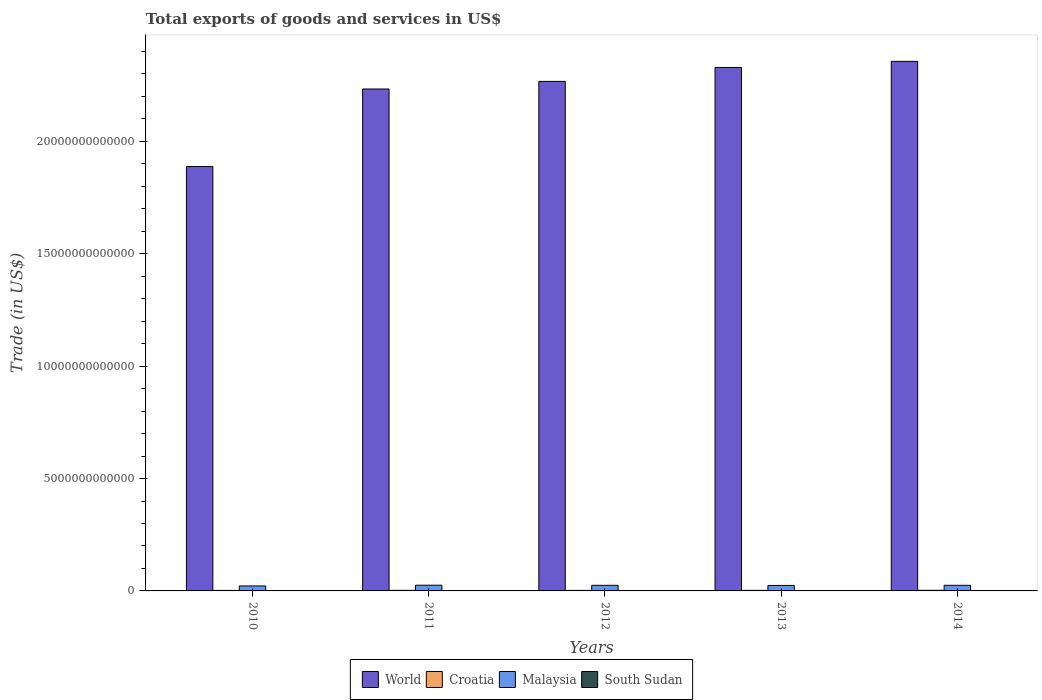How many different coloured bars are there?
Provide a short and direct response. 4. Are the number of bars on each tick of the X-axis equal?
Your answer should be very brief. Yes. How many bars are there on the 5th tick from the left?
Ensure brevity in your answer.  4. What is the label of the 5th group of bars from the left?
Your answer should be very brief. 2014. What is the total exports of goods and services in Malaysia in 2012?
Ensure brevity in your answer.  2.49e+11. Across all years, what is the maximum total exports of goods and services in Malaysia?
Give a very brief answer. 2.54e+11. Across all years, what is the minimum total exports of goods and services in World?
Give a very brief answer. 1.89e+13. In which year was the total exports of goods and services in World minimum?
Provide a short and direct response. 2010. What is the total total exports of goods and services in World in the graph?
Give a very brief answer. 1.11e+14. What is the difference between the total exports of goods and services in Croatia in 2010 and that in 2014?
Give a very brief answer. -3.91e+09. What is the difference between the total exports of goods and services in Malaysia in 2010 and the total exports of goods and services in Croatia in 2013?
Offer a very short reply. 1.97e+11. What is the average total exports of goods and services in World per year?
Offer a terse response. 2.21e+13. In the year 2013, what is the difference between the total exports of goods and services in Malaysia and total exports of goods and services in World?
Offer a very short reply. -2.30e+13. In how many years, is the total exports of goods and services in South Sudan greater than 4000000000000 US$?
Make the answer very short. 0. What is the ratio of the total exports of goods and services in Croatia in 2011 to that in 2014?
Give a very brief answer. 0.95. Is the total exports of goods and services in South Sudan in 2010 less than that in 2013?
Your answer should be very brief. No. What is the difference between the highest and the second highest total exports of goods and services in Croatia?
Provide a succinct answer. 1.28e+09. What is the difference between the highest and the lowest total exports of goods and services in Malaysia?
Offer a terse response. 3.23e+1. In how many years, is the total exports of goods and services in Malaysia greater than the average total exports of goods and services in Malaysia taken over all years?
Your response must be concise. 4. Is the sum of the total exports of goods and services in South Sudan in 2012 and 2013 greater than the maximum total exports of goods and services in World across all years?
Give a very brief answer. No. Is it the case that in every year, the sum of the total exports of goods and services in Croatia and total exports of goods and services in World is greater than the sum of total exports of goods and services in South Sudan and total exports of goods and services in Malaysia?
Offer a terse response. No. What does the 4th bar from the left in 2013 represents?
Give a very brief answer. South Sudan. What does the 3rd bar from the right in 2013 represents?
Offer a very short reply. Croatia. How many bars are there?
Give a very brief answer. 20. Are all the bars in the graph horizontal?
Offer a terse response. No. What is the difference between two consecutive major ticks on the Y-axis?
Your answer should be compact. 5.00e+12. Are the values on the major ticks of Y-axis written in scientific E-notation?
Offer a terse response. No. Does the graph contain grids?
Keep it short and to the point. No. Where does the legend appear in the graph?
Your response must be concise. Bottom center. What is the title of the graph?
Ensure brevity in your answer.  Total exports of goods and services in US$. Does "Kuwait" appear as one of the legend labels in the graph?
Your response must be concise. No. What is the label or title of the Y-axis?
Offer a terse response. Trade (in US$). What is the Trade (in US$) of World in 2010?
Provide a succinct answer. 1.89e+13. What is the Trade (in US$) of Croatia in 2010?
Offer a terse response. 2.25e+1. What is the Trade (in US$) of Malaysia in 2010?
Make the answer very short. 2.22e+11. What is the Trade (in US$) of South Sudan in 2010?
Give a very brief answer. 9.66e+09. What is the Trade (in US$) of World in 2011?
Provide a succinct answer. 2.23e+13. What is the Trade (in US$) of Croatia in 2011?
Provide a succinct answer. 2.52e+1. What is the Trade (in US$) of Malaysia in 2011?
Your response must be concise. 2.54e+11. What is the Trade (in US$) in South Sudan in 2011?
Offer a terse response. 1.18e+1. What is the Trade (in US$) in World in 2012?
Provide a short and direct response. 2.27e+13. What is the Trade (in US$) of Croatia in 2012?
Ensure brevity in your answer.  2.35e+1. What is the Trade (in US$) in Malaysia in 2012?
Provide a short and direct response. 2.49e+11. What is the Trade (in US$) of South Sudan in 2012?
Ensure brevity in your answer.  1.05e+09. What is the Trade (in US$) in World in 2013?
Your response must be concise. 2.33e+13. What is the Trade (in US$) in Croatia in 2013?
Provide a short and direct response. 2.49e+1. What is the Trade (in US$) in Malaysia in 2013?
Offer a terse response. 2.44e+11. What is the Trade (in US$) in South Sudan in 2013?
Your answer should be compact. 2.15e+09. What is the Trade (in US$) of World in 2014?
Offer a very short reply. 2.36e+13. What is the Trade (in US$) in Croatia in 2014?
Offer a terse response. 2.64e+1. What is the Trade (in US$) of Malaysia in 2014?
Provide a succinct answer. 2.50e+11. What is the Trade (in US$) of South Sudan in 2014?
Offer a terse response. 2.68e+09. Across all years, what is the maximum Trade (in US$) in World?
Give a very brief answer. 2.36e+13. Across all years, what is the maximum Trade (in US$) in Croatia?
Keep it short and to the point. 2.64e+1. Across all years, what is the maximum Trade (in US$) in Malaysia?
Make the answer very short. 2.54e+11. Across all years, what is the maximum Trade (in US$) of South Sudan?
Provide a short and direct response. 1.18e+1. Across all years, what is the minimum Trade (in US$) of World?
Your answer should be compact. 1.89e+13. Across all years, what is the minimum Trade (in US$) of Croatia?
Offer a very short reply. 2.25e+1. Across all years, what is the minimum Trade (in US$) of Malaysia?
Offer a terse response. 2.22e+11. Across all years, what is the minimum Trade (in US$) of South Sudan?
Offer a very short reply. 1.05e+09. What is the total Trade (in US$) in World in the graph?
Offer a terse response. 1.11e+14. What is the total Trade (in US$) in Croatia in the graph?
Your response must be concise. 1.22e+11. What is the total Trade (in US$) in Malaysia in the graph?
Ensure brevity in your answer.  1.22e+12. What is the total Trade (in US$) in South Sudan in the graph?
Make the answer very short. 2.73e+1. What is the difference between the Trade (in US$) in World in 2010 and that in 2011?
Offer a very short reply. -3.45e+12. What is the difference between the Trade (in US$) in Croatia in 2010 and that in 2011?
Give a very brief answer. -2.63e+09. What is the difference between the Trade (in US$) of Malaysia in 2010 and that in 2011?
Make the answer very short. -3.23e+1. What is the difference between the Trade (in US$) in South Sudan in 2010 and that in 2011?
Offer a very short reply. -2.12e+09. What is the difference between the Trade (in US$) in World in 2010 and that in 2012?
Provide a succinct answer. -3.79e+12. What is the difference between the Trade (in US$) of Croatia in 2010 and that in 2012?
Your answer should be very brief. -9.61e+08. What is the difference between the Trade (in US$) of Malaysia in 2010 and that in 2012?
Provide a short and direct response. -2.77e+1. What is the difference between the Trade (in US$) in South Sudan in 2010 and that in 2012?
Offer a very short reply. 8.61e+09. What is the difference between the Trade (in US$) of World in 2010 and that in 2013?
Your answer should be very brief. -4.41e+12. What is the difference between the Trade (in US$) of Croatia in 2010 and that in 2013?
Your response must be concise. -2.34e+09. What is the difference between the Trade (in US$) in Malaysia in 2010 and that in 2013?
Offer a terse response. -2.28e+1. What is the difference between the Trade (in US$) of South Sudan in 2010 and that in 2013?
Your answer should be very brief. 7.51e+09. What is the difference between the Trade (in US$) of World in 2010 and that in 2014?
Make the answer very short. -4.68e+12. What is the difference between the Trade (in US$) of Croatia in 2010 and that in 2014?
Your answer should be compact. -3.91e+09. What is the difference between the Trade (in US$) in Malaysia in 2010 and that in 2014?
Provide a short and direct response. -2.80e+1. What is the difference between the Trade (in US$) of South Sudan in 2010 and that in 2014?
Ensure brevity in your answer.  6.99e+09. What is the difference between the Trade (in US$) in World in 2011 and that in 2012?
Your answer should be compact. -3.38e+11. What is the difference between the Trade (in US$) in Croatia in 2011 and that in 2012?
Provide a short and direct response. 1.67e+09. What is the difference between the Trade (in US$) in Malaysia in 2011 and that in 2012?
Make the answer very short. 4.67e+09. What is the difference between the Trade (in US$) of South Sudan in 2011 and that in 2012?
Offer a very short reply. 1.07e+1. What is the difference between the Trade (in US$) in World in 2011 and that in 2013?
Offer a very short reply. -9.57e+11. What is the difference between the Trade (in US$) of Croatia in 2011 and that in 2013?
Your answer should be very brief. 2.94e+08. What is the difference between the Trade (in US$) in Malaysia in 2011 and that in 2013?
Give a very brief answer. 9.53e+09. What is the difference between the Trade (in US$) of South Sudan in 2011 and that in 2013?
Give a very brief answer. 9.63e+09. What is the difference between the Trade (in US$) of World in 2011 and that in 2014?
Provide a short and direct response. -1.23e+12. What is the difference between the Trade (in US$) of Croatia in 2011 and that in 2014?
Your answer should be very brief. -1.28e+09. What is the difference between the Trade (in US$) in Malaysia in 2011 and that in 2014?
Make the answer very short. 4.34e+09. What is the difference between the Trade (in US$) of South Sudan in 2011 and that in 2014?
Your response must be concise. 9.10e+09. What is the difference between the Trade (in US$) in World in 2012 and that in 2013?
Your answer should be compact. -6.19e+11. What is the difference between the Trade (in US$) of Croatia in 2012 and that in 2013?
Make the answer very short. -1.38e+09. What is the difference between the Trade (in US$) in Malaysia in 2012 and that in 2013?
Offer a very short reply. 4.86e+09. What is the difference between the Trade (in US$) in South Sudan in 2012 and that in 2013?
Your response must be concise. -1.10e+09. What is the difference between the Trade (in US$) of World in 2012 and that in 2014?
Make the answer very short. -8.91e+11. What is the difference between the Trade (in US$) in Croatia in 2012 and that in 2014?
Make the answer very short. -2.95e+09. What is the difference between the Trade (in US$) of Malaysia in 2012 and that in 2014?
Ensure brevity in your answer.  -3.27e+08. What is the difference between the Trade (in US$) in South Sudan in 2012 and that in 2014?
Offer a very short reply. -1.63e+09. What is the difference between the Trade (in US$) of World in 2013 and that in 2014?
Provide a short and direct response. -2.72e+11. What is the difference between the Trade (in US$) of Croatia in 2013 and that in 2014?
Offer a terse response. -1.57e+09. What is the difference between the Trade (in US$) of Malaysia in 2013 and that in 2014?
Offer a terse response. -5.19e+09. What is the difference between the Trade (in US$) in South Sudan in 2013 and that in 2014?
Give a very brief answer. -5.29e+08. What is the difference between the Trade (in US$) of World in 2010 and the Trade (in US$) of Croatia in 2011?
Provide a succinct answer. 1.89e+13. What is the difference between the Trade (in US$) in World in 2010 and the Trade (in US$) in Malaysia in 2011?
Your response must be concise. 1.86e+13. What is the difference between the Trade (in US$) of World in 2010 and the Trade (in US$) of South Sudan in 2011?
Your response must be concise. 1.89e+13. What is the difference between the Trade (in US$) of Croatia in 2010 and the Trade (in US$) of Malaysia in 2011?
Offer a terse response. -2.31e+11. What is the difference between the Trade (in US$) in Croatia in 2010 and the Trade (in US$) in South Sudan in 2011?
Give a very brief answer. 1.07e+1. What is the difference between the Trade (in US$) of Malaysia in 2010 and the Trade (in US$) of South Sudan in 2011?
Your answer should be compact. 2.10e+11. What is the difference between the Trade (in US$) of World in 2010 and the Trade (in US$) of Croatia in 2012?
Offer a terse response. 1.89e+13. What is the difference between the Trade (in US$) of World in 2010 and the Trade (in US$) of Malaysia in 2012?
Your answer should be very brief. 1.86e+13. What is the difference between the Trade (in US$) of World in 2010 and the Trade (in US$) of South Sudan in 2012?
Make the answer very short. 1.89e+13. What is the difference between the Trade (in US$) of Croatia in 2010 and the Trade (in US$) of Malaysia in 2012?
Your response must be concise. -2.27e+11. What is the difference between the Trade (in US$) in Croatia in 2010 and the Trade (in US$) in South Sudan in 2012?
Provide a short and direct response. 2.15e+1. What is the difference between the Trade (in US$) in Malaysia in 2010 and the Trade (in US$) in South Sudan in 2012?
Ensure brevity in your answer.  2.21e+11. What is the difference between the Trade (in US$) of World in 2010 and the Trade (in US$) of Croatia in 2013?
Your answer should be very brief. 1.89e+13. What is the difference between the Trade (in US$) in World in 2010 and the Trade (in US$) in Malaysia in 2013?
Keep it short and to the point. 1.86e+13. What is the difference between the Trade (in US$) of World in 2010 and the Trade (in US$) of South Sudan in 2013?
Your response must be concise. 1.89e+13. What is the difference between the Trade (in US$) of Croatia in 2010 and the Trade (in US$) of Malaysia in 2013?
Your response must be concise. -2.22e+11. What is the difference between the Trade (in US$) in Croatia in 2010 and the Trade (in US$) in South Sudan in 2013?
Give a very brief answer. 2.04e+1. What is the difference between the Trade (in US$) in Malaysia in 2010 and the Trade (in US$) in South Sudan in 2013?
Give a very brief answer. 2.20e+11. What is the difference between the Trade (in US$) of World in 2010 and the Trade (in US$) of Croatia in 2014?
Provide a short and direct response. 1.89e+13. What is the difference between the Trade (in US$) of World in 2010 and the Trade (in US$) of Malaysia in 2014?
Offer a terse response. 1.86e+13. What is the difference between the Trade (in US$) in World in 2010 and the Trade (in US$) in South Sudan in 2014?
Keep it short and to the point. 1.89e+13. What is the difference between the Trade (in US$) of Croatia in 2010 and the Trade (in US$) of Malaysia in 2014?
Provide a succinct answer. -2.27e+11. What is the difference between the Trade (in US$) in Croatia in 2010 and the Trade (in US$) in South Sudan in 2014?
Offer a terse response. 1.98e+1. What is the difference between the Trade (in US$) in Malaysia in 2010 and the Trade (in US$) in South Sudan in 2014?
Your answer should be compact. 2.19e+11. What is the difference between the Trade (in US$) in World in 2011 and the Trade (in US$) in Croatia in 2012?
Offer a very short reply. 2.23e+13. What is the difference between the Trade (in US$) of World in 2011 and the Trade (in US$) of Malaysia in 2012?
Your response must be concise. 2.21e+13. What is the difference between the Trade (in US$) in World in 2011 and the Trade (in US$) in South Sudan in 2012?
Offer a terse response. 2.23e+13. What is the difference between the Trade (in US$) of Croatia in 2011 and the Trade (in US$) of Malaysia in 2012?
Provide a short and direct response. -2.24e+11. What is the difference between the Trade (in US$) in Croatia in 2011 and the Trade (in US$) in South Sudan in 2012?
Ensure brevity in your answer.  2.41e+1. What is the difference between the Trade (in US$) in Malaysia in 2011 and the Trade (in US$) in South Sudan in 2012?
Your answer should be very brief. 2.53e+11. What is the difference between the Trade (in US$) of World in 2011 and the Trade (in US$) of Croatia in 2013?
Your answer should be very brief. 2.23e+13. What is the difference between the Trade (in US$) of World in 2011 and the Trade (in US$) of Malaysia in 2013?
Give a very brief answer. 2.21e+13. What is the difference between the Trade (in US$) of World in 2011 and the Trade (in US$) of South Sudan in 2013?
Your response must be concise. 2.23e+13. What is the difference between the Trade (in US$) of Croatia in 2011 and the Trade (in US$) of Malaysia in 2013?
Offer a very short reply. -2.19e+11. What is the difference between the Trade (in US$) of Croatia in 2011 and the Trade (in US$) of South Sudan in 2013?
Make the answer very short. 2.30e+1. What is the difference between the Trade (in US$) of Malaysia in 2011 and the Trade (in US$) of South Sudan in 2013?
Your response must be concise. 2.52e+11. What is the difference between the Trade (in US$) of World in 2011 and the Trade (in US$) of Croatia in 2014?
Provide a succinct answer. 2.23e+13. What is the difference between the Trade (in US$) of World in 2011 and the Trade (in US$) of Malaysia in 2014?
Your response must be concise. 2.21e+13. What is the difference between the Trade (in US$) of World in 2011 and the Trade (in US$) of South Sudan in 2014?
Provide a short and direct response. 2.23e+13. What is the difference between the Trade (in US$) of Croatia in 2011 and the Trade (in US$) of Malaysia in 2014?
Provide a short and direct response. -2.25e+11. What is the difference between the Trade (in US$) of Croatia in 2011 and the Trade (in US$) of South Sudan in 2014?
Provide a succinct answer. 2.25e+1. What is the difference between the Trade (in US$) of Malaysia in 2011 and the Trade (in US$) of South Sudan in 2014?
Your answer should be compact. 2.51e+11. What is the difference between the Trade (in US$) in World in 2012 and the Trade (in US$) in Croatia in 2013?
Your response must be concise. 2.26e+13. What is the difference between the Trade (in US$) in World in 2012 and the Trade (in US$) in Malaysia in 2013?
Give a very brief answer. 2.24e+13. What is the difference between the Trade (in US$) in World in 2012 and the Trade (in US$) in South Sudan in 2013?
Give a very brief answer. 2.27e+13. What is the difference between the Trade (in US$) in Croatia in 2012 and the Trade (in US$) in Malaysia in 2013?
Your response must be concise. -2.21e+11. What is the difference between the Trade (in US$) in Croatia in 2012 and the Trade (in US$) in South Sudan in 2013?
Provide a succinct answer. 2.13e+1. What is the difference between the Trade (in US$) of Malaysia in 2012 and the Trade (in US$) of South Sudan in 2013?
Make the answer very short. 2.47e+11. What is the difference between the Trade (in US$) in World in 2012 and the Trade (in US$) in Croatia in 2014?
Give a very brief answer. 2.26e+13. What is the difference between the Trade (in US$) in World in 2012 and the Trade (in US$) in Malaysia in 2014?
Offer a very short reply. 2.24e+13. What is the difference between the Trade (in US$) in World in 2012 and the Trade (in US$) in South Sudan in 2014?
Keep it short and to the point. 2.27e+13. What is the difference between the Trade (in US$) of Croatia in 2012 and the Trade (in US$) of Malaysia in 2014?
Provide a short and direct response. -2.26e+11. What is the difference between the Trade (in US$) in Croatia in 2012 and the Trade (in US$) in South Sudan in 2014?
Provide a short and direct response. 2.08e+1. What is the difference between the Trade (in US$) in Malaysia in 2012 and the Trade (in US$) in South Sudan in 2014?
Provide a succinct answer. 2.47e+11. What is the difference between the Trade (in US$) in World in 2013 and the Trade (in US$) in Croatia in 2014?
Your answer should be very brief. 2.33e+13. What is the difference between the Trade (in US$) of World in 2013 and the Trade (in US$) of Malaysia in 2014?
Keep it short and to the point. 2.30e+13. What is the difference between the Trade (in US$) in World in 2013 and the Trade (in US$) in South Sudan in 2014?
Make the answer very short. 2.33e+13. What is the difference between the Trade (in US$) in Croatia in 2013 and the Trade (in US$) in Malaysia in 2014?
Offer a terse response. -2.25e+11. What is the difference between the Trade (in US$) of Croatia in 2013 and the Trade (in US$) of South Sudan in 2014?
Your answer should be very brief. 2.22e+1. What is the difference between the Trade (in US$) of Malaysia in 2013 and the Trade (in US$) of South Sudan in 2014?
Offer a terse response. 2.42e+11. What is the average Trade (in US$) in World per year?
Provide a short and direct response. 2.21e+13. What is the average Trade (in US$) of Croatia per year?
Keep it short and to the point. 2.45e+1. What is the average Trade (in US$) of Malaysia per year?
Ensure brevity in your answer.  2.44e+11. What is the average Trade (in US$) in South Sudan per year?
Offer a terse response. 5.46e+09. In the year 2010, what is the difference between the Trade (in US$) of World and Trade (in US$) of Croatia?
Ensure brevity in your answer.  1.89e+13. In the year 2010, what is the difference between the Trade (in US$) in World and Trade (in US$) in Malaysia?
Your answer should be very brief. 1.87e+13. In the year 2010, what is the difference between the Trade (in US$) in World and Trade (in US$) in South Sudan?
Your answer should be compact. 1.89e+13. In the year 2010, what is the difference between the Trade (in US$) of Croatia and Trade (in US$) of Malaysia?
Your answer should be compact. -1.99e+11. In the year 2010, what is the difference between the Trade (in US$) in Croatia and Trade (in US$) in South Sudan?
Offer a very short reply. 1.29e+1. In the year 2010, what is the difference between the Trade (in US$) in Malaysia and Trade (in US$) in South Sudan?
Provide a succinct answer. 2.12e+11. In the year 2011, what is the difference between the Trade (in US$) of World and Trade (in US$) of Croatia?
Provide a succinct answer. 2.23e+13. In the year 2011, what is the difference between the Trade (in US$) in World and Trade (in US$) in Malaysia?
Ensure brevity in your answer.  2.21e+13. In the year 2011, what is the difference between the Trade (in US$) in World and Trade (in US$) in South Sudan?
Ensure brevity in your answer.  2.23e+13. In the year 2011, what is the difference between the Trade (in US$) of Croatia and Trade (in US$) of Malaysia?
Provide a short and direct response. -2.29e+11. In the year 2011, what is the difference between the Trade (in US$) in Croatia and Trade (in US$) in South Sudan?
Ensure brevity in your answer.  1.34e+1. In the year 2011, what is the difference between the Trade (in US$) in Malaysia and Trade (in US$) in South Sudan?
Ensure brevity in your answer.  2.42e+11. In the year 2012, what is the difference between the Trade (in US$) of World and Trade (in US$) of Croatia?
Keep it short and to the point. 2.26e+13. In the year 2012, what is the difference between the Trade (in US$) of World and Trade (in US$) of Malaysia?
Your answer should be very brief. 2.24e+13. In the year 2012, what is the difference between the Trade (in US$) of World and Trade (in US$) of South Sudan?
Offer a very short reply. 2.27e+13. In the year 2012, what is the difference between the Trade (in US$) of Croatia and Trade (in US$) of Malaysia?
Offer a very short reply. -2.26e+11. In the year 2012, what is the difference between the Trade (in US$) of Croatia and Trade (in US$) of South Sudan?
Provide a succinct answer. 2.24e+1. In the year 2012, what is the difference between the Trade (in US$) of Malaysia and Trade (in US$) of South Sudan?
Ensure brevity in your answer.  2.48e+11. In the year 2013, what is the difference between the Trade (in US$) in World and Trade (in US$) in Croatia?
Provide a succinct answer. 2.33e+13. In the year 2013, what is the difference between the Trade (in US$) in World and Trade (in US$) in Malaysia?
Provide a succinct answer. 2.30e+13. In the year 2013, what is the difference between the Trade (in US$) of World and Trade (in US$) of South Sudan?
Give a very brief answer. 2.33e+13. In the year 2013, what is the difference between the Trade (in US$) of Croatia and Trade (in US$) of Malaysia?
Your answer should be compact. -2.20e+11. In the year 2013, what is the difference between the Trade (in US$) of Croatia and Trade (in US$) of South Sudan?
Provide a short and direct response. 2.27e+1. In the year 2013, what is the difference between the Trade (in US$) in Malaysia and Trade (in US$) in South Sudan?
Your answer should be very brief. 2.42e+11. In the year 2014, what is the difference between the Trade (in US$) in World and Trade (in US$) in Croatia?
Your answer should be compact. 2.35e+13. In the year 2014, what is the difference between the Trade (in US$) in World and Trade (in US$) in Malaysia?
Give a very brief answer. 2.33e+13. In the year 2014, what is the difference between the Trade (in US$) in World and Trade (in US$) in South Sudan?
Provide a succinct answer. 2.36e+13. In the year 2014, what is the difference between the Trade (in US$) in Croatia and Trade (in US$) in Malaysia?
Offer a terse response. -2.23e+11. In the year 2014, what is the difference between the Trade (in US$) in Croatia and Trade (in US$) in South Sudan?
Ensure brevity in your answer.  2.38e+1. In the year 2014, what is the difference between the Trade (in US$) of Malaysia and Trade (in US$) of South Sudan?
Provide a short and direct response. 2.47e+11. What is the ratio of the Trade (in US$) in World in 2010 to that in 2011?
Provide a succinct answer. 0.85. What is the ratio of the Trade (in US$) in Croatia in 2010 to that in 2011?
Your answer should be compact. 0.9. What is the ratio of the Trade (in US$) of Malaysia in 2010 to that in 2011?
Your answer should be very brief. 0.87. What is the ratio of the Trade (in US$) of South Sudan in 2010 to that in 2011?
Give a very brief answer. 0.82. What is the ratio of the Trade (in US$) of World in 2010 to that in 2012?
Your answer should be compact. 0.83. What is the ratio of the Trade (in US$) in Croatia in 2010 to that in 2012?
Give a very brief answer. 0.96. What is the ratio of the Trade (in US$) of Malaysia in 2010 to that in 2012?
Give a very brief answer. 0.89. What is the ratio of the Trade (in US$) of South Sudan in 2010 to that in 2012?
Your response must be concise. 9.21. What is the ratio of the Trade (in US$) in World in 2010 to that in 2013?
Your answer should be compact. 0.81. What is the ratio of the Trade (in US$) in Croatia in 2010 to that in 2013?
Make the answer very short. 0.91. What is the ratio of the Trade (in US$) in Malaysia in 2010 to that in 2013?
Offer a terse response. 0.91. What is the ratio of the Trade (in US$) of South Sudan in 2010 to that in 2013?
Your response must be concise. 4.5. What is the ratio of the Trade (in US$) in World in 2010 to that in 2014?
Give a very brief answer. 0.8. What is the ratio of the Trade (in US$) in Croatia in 2010 to that in 2014?
Keep it short and to the point. 0.85. What is the ratio of the Trade (in US$) of Malaysia in 2010 to that in 2014?
Keep it short and to the point. 0.89. What is the ratio of the Trade (in US$) of South Sudan in 2010 to that in 2014?
Ensure brevity in your answer.  3.61. What is the ratio of the Trade (in US$) of World in 2011 to that in 2012?
Your answer should be compact. 0.99. What is the ratio of the Trade (in US$) in Croatia in 2011 to that in 2012?
Provide a short and direct response. 1.07. What is the ratio of the Trade (in US$) of Malaysia in 2011 to that in 2012?
Your answer should be very brief. 1.02. What is the ratio of the Trade (in US$) in South Sudan in 2011 to that in 2012?
Your answer should be very brief. 11.22. What is the ratio of the Trade (in US$) of World in 2011 to that in 2013?
Offer a terse response. 0.96. What is the ratio of the Trade (in US$) in Croatia in 2011 to that in 2013?
Provide a succinct answer. 1.01. What is the ratio of the Trade (in US$) of Malaysia in 2011 to that in 2013?
Your answer should be very brief. 1.04. What is the ratio of the Trade (in US$) in South Sudan in 2011 to that in 2013?
Your response must be concise. 5.49. What is the ratio of the Trade (in US$) in World in 2011 to that in 2014?
Offer a terse response. 0.95. What is the ratio of the Trade (in US$) of Croatia in 2011 to that in 2014?
Your answer should be compact. 0.95. What is the ratio of the Trade (in US$) in Malaysia in 2011 to that in 2014?
Offer a terse response. 1.02. What is the ratio of the Trade (in US$) in South Sudan in 2011 to that in 2014?
Provide a short and direct response. 4.4. What is the ratio of the Trade (in US$) of World in 2012 to that in 2013?
Your response must be concise. 0.97. What is the ratio of the Trade (in US$) in Croatia in 2012 to that in 2013?
Offer a terse response. 0.94. What is the ratio of the Trade (in US$) of Malaysia in 2012 to that in 2013?
Keep it short and to the point. 1.02. What is the ratio of the Trade (in US$) in South Sudan in 2012 to that in 2013?
Offer a very short reply. 0.49. What is the ratio of the Trade (in US$) of World in 2012 to that in 2014?
Give a very brief answer. 0.96. What is the ratio of the Trade (in US$) of Croatia in 2012 to that in 2014?
Offer a terse response. 0.89. What is the ratio of the Trade (in US$) in Malaysia in 2012 to that in 2014?
Offer a terse response. 1. What is the ratio of the Trade (in US$) in South Sudan in 2012 to that in 2014?
Give a very brief answer. 0.39. What is the ratio of the Trade (in US$) of World in 2013 to that in 2014?
Keep it short and to the point. 0.99. What is the ratio of the Trade (in US$) of Croatia in 2013 to that in 2014?
Your response must be concise. 0.94. What is the ratio of the Trade (in US$) in Malaysia in 2013 to that in 2014?
Offer a very short reply. 0.98. What is the ratio of the Trade (in US$) of South Sudan in 2013 to that in 2014?
Ensure brevity in your answer.  0.8. What is the difference between the highest and the second highest Trade (in US$) of World?
Give a very brief answer. 2.72e+11. What is the difference between the highest and the second highest Trade (in US$) in Croatia?
Your response must be concise. 1.28e+09. What is the difference between the highest and the second highest Trade (in US$) in Malaysia?
Your answer should be compact. 4.34e+09. What is the difference between the highest and the second highest Trade (in US$) in South Sudan?
Your answer should be very brief. 2.12e+09. What is the difference between the highest and the lowest Trade (in US$) of World?
Offer a very short reply. 4.68e+12. What is the difference between the highest and the lowest Trade (in US$) of Croatia?
Your answer should be very brief. 3.91e+09. What is the difference between the highest and the lowest Trade (in US$) of Malaysia?
Make the answer very short. 3.23e+1. What is the difference between the highest and the lowest Trade (in US$) in South Sudan?
Provide a succinct answer. 1.07e+1. 